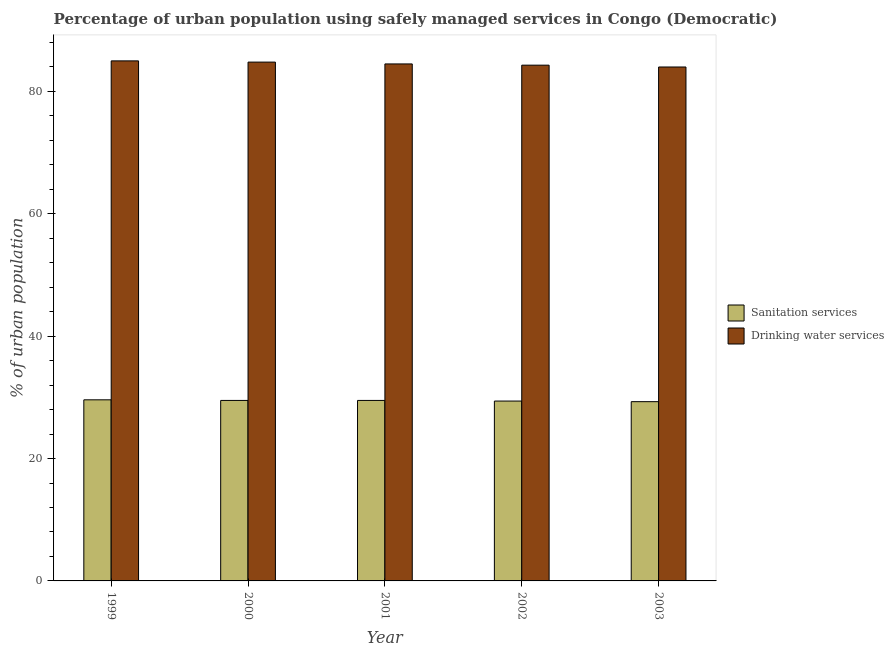Are the number of bars per tick equal to the number of legend labels?
Give a very brief answer. Yes. Are the number of bars on each tick of the X-axis equal?
Your answer should be very brief. Yes. How many bars are there on the 1st tick from the left?
Provide a short and direct response. 2. What is the percentage of urban population who used sanitation services in 2000?
Make the answer very short. 29.5. Across all years, what is the maximum percentage of urban population who used sanitation services?
Provide a succinct answer. 29.6. Across all years, what is the minimum percentage of urban population who used drinking water services?
Keep it short and to the point. 84. In which year was the percentage of urban population who used sanitation services maximum?
Your answer should be compact. 1999. In which year was the percentage of urban population who used drinking water services minimum?
Offer a very short reply. 2003. What is the total percentage of urban population who used sanitation services in the graph?
Ensure brevity in your answer.  147.3. What is the difference between the percentage of urban population who used sanitation services in 2000 and that in 2003?
Offer a terse response. 0.2. What is the difference between the percentage of urban population who used sanitation services in 2000 and the percentage of urban population who used drinking water services in 2002?
Your response must be concise. 0.1. What is the average percentage of urban population who used sanitation services per year?
Provide a short and direct response. 29.46. What is the ratio of the percentage of urban population who used drinking water services in 1999 to that in 2001?
Provide a short and direct response. 1.01. What is the difference between the highest and the second highest percentage of urban population who used drinking water services?
Give a very brief answer. 0.2. Is the sum of the percentage of urban population who used sanitation services in 1999 and 2003 greater than the maximum percentage of urban population who used drinking water services across all years?
Offer a very short reply. Yes. What does the 1st bar from the left in 2002 represents?
Make the answer very short. Sanitation services. What does the 1st bar from the right in 1999 represents?
Ensure brevity in your answer.  Drinking water services. Are all the bars in the graph horizontal?
Give a very brief answer. No. How many years are there in the graph?
Your answer should be compact. 5. What is the difference between two consecutive major ticks on the Y-axis?
Your answer should be compact. 20. Does the graph contain any zero values?
Give a very brief answer. No. Does the graph contain grids?
Ensure brevity in your answer.  No. Where does the legend appear in the graph?
Offer a very short reply. Center right. What is the title of the graph?
Offer a very short reply. Percentage of urban population using safely managed services in Congo (Democratic). What is the label or title of the Y-axis?
Your answer should be compact. % of urban population. What is the % of urban population in Sanitation services in 1999?
Your response must be concise. 29.6. What is the % of urban population in Sanitation services in 2000?
Your response must be concise. 29.5. What is the % of urban population in Drinking water services in 2000?
Your answer should be very brief. 84.8. What is the % of urban population of Sanitation services in 2001?
Your response must be concise. 29.5. What is the % of urban population of Drinking water services in 2001?
Provide a short and direct response. 84.5. What is the % of urban population of Sanitation services in 2002?
Keep it short and to the point. 29.4. What is the % of urban population in Drinking water services in 2002?
Offer a terse response. 84.3. What is the % of urban population of Sanitation services in 2003?
Your answer should be very brief. 29.3. Across all years, what is the maximum % of urban population of Sanitation services?
Your answer should be very brief. 29.6. Across all years, what is the minimum % of urban population in Sanitation services?
Your answer should be very brief. 29.3. What is the total % of urban population in Sanitation services in the graph?
Provide a short and direct response. 147.3. What is the total % of urban population in Drinking water services in the graph?
Provide a short and direct response. 422.6. What is the difference between the % of urban population of Sanitation services in 1999 and that in 2001?
Your answer should be compact. 0.1. What is the difference between the % of urban population of Sanitation services in 1999 and that in 2002?
Give a very brief answer. 0.2. What is the difference between the % of urban population in Drinking water services in 1999 and that in 2003?
Offer a very short reply. 1. What is the difference between the % of urban population in Drinking water services in 2000 and that in 2001?
Provide a short and direct response. 0.3. What is the difference between the % of urban population of Drinking water services in 2001 and that in 2002?
Give a very brief answer. 0.2. What is the difference between the % of urban population in Sanitation services in 2002 and that in 2003?
Your answer should be compact. 0.1. What is the difference between the % of urban population of Sanitation services in 1999 and the % of urban population of Drinking water services in 2000?
Your answer should be very brief. -55.2. What is the difference between the % of urban population of Sanitation services in 1999 and the % of urban population of Drinking water services in 2001?
Give a very brief answer. -54.9. What is the difference between the % of urban population of Sanitation services in 1999 and the % of urban population of Drinking water services in 2002?
Provide a succinct answer. -54.7. What is the difference between the % of urban population in Sanitation services in 1999 and the % of urban population in Drinking water services in 2003?
Your answer should be compact. -54.4. What is the difference between the % of urban population of Sanitation services in 2000 and the % of urban population of Drinking water services in 2001?
Make the answer very short. -55. What is the difference between the % of urban population in Sanitation services in 2000 and the % of urban population in Drinking water services in 2002?
Keep it short and to the point. -54.8. What is the difference between the % of urban population in Sanitation services in 2000 and the % of urban population in Drinking water services in 2003?
Provide a short and direct response. -54.5. What is the difference between the % of urban population in Sanitation services in 2001 and the % of urban population in Drinking water services in 2002?
Keep it short and to the point. -54.8. What is the difference between the % of urban population of Sanitation services in 2001 and the % of urban population of Drinking water services in 2003?
Offer a very short reply. -54.5. What is the difference between the % of urban population of Sanitation services in 2002 and the % of urban population of Drinking water services in 2003?
Make the answer very short. -54.6. What is the average % of urban population in Sanitation services per year?
Make the answer very short. 29.46. What is the average % of urban population of Drinking water services per year?
Give a very brief answer. 84.52. In the year 1999, what is the difference between the % of urban population of Sanitation services and % of urban population of Drinking water services?
Keep it short and to the point. -55.4. In the year 2000, what is the difference between the % of urban population in Sanitation services and % of urban population in Drinking water services?
Your answer should be very brief. -55.3. In the year 2001, what is the difference between the % of urban population in Sanitation services and % of urban population in Drinking water services?
Your answer should be very brief. -55. In the year 2002, what is the difference between the % of urban population in Sanitation services and % of urban population in Drinking water services?
Your answer should be very brief. -54.9. In the year 2003, what is the difference between the % of urban population of Sanitation services and % of urban population of Drinking water services?
Offer a very short reply. -54.7. What is the ratio of the % of urban population of Drinking water services in 1999 to that in 2000?
Provide a short and direct response. 1. What is the ratio of the % of urban population in Sanitation services in 1999 to that in 2001?
Provide a short and direct response. 1. What is the ratio of the % of urban population of Drinking water services in 1999 to that in 2001?
Your answer should be very brief. 1.01. What is the ratio of the % of urban population in Sanitation services in 1999 to that in 2002?
Provide a short and direct response. 1.01. What is the ratio of the % of urban population of Drinking water services in 1999 to that in 2002?
Your answer should be compact. 1.01. What is the ratio of the % of urban population in Sanitation services in 1999 to that in 2003?
Your response must be concise. 1.01. What is the ratio of the % of urban population of Drinking water services in 1999 to that in 2003?
Give a very brief answer. 1.01. What is the ratio of the % of urban population of Drinking water services in 2000 to that in 2002?
Offer a terse response. 1.01. What is the ratio of the % of urban population of Sanitation services in 2000 to that in 2003?
Keep it short and to the point. 1.01. What is the ratio of the % of urban population in Drinking water services in 2000 to that in 2003?
Your answer should be very brief. 1.01. What is the ratio of the % of urban population in Sanitation services in 2001 to that in 2003?
Ensure brevity in your answer.  1.01. What is the ratio of the % of urban population in Drinking water services in 2001 to that in 2003?
Offer a very short reply. 1.01. What is the difference between the highest and the second highest % of urban population in Sanitation services?
Your answer should be very brief. 0.1. What is the difference between the highest and the lowest % of urban population of Sanitation services?
Give a very brief answer. 0.3. 